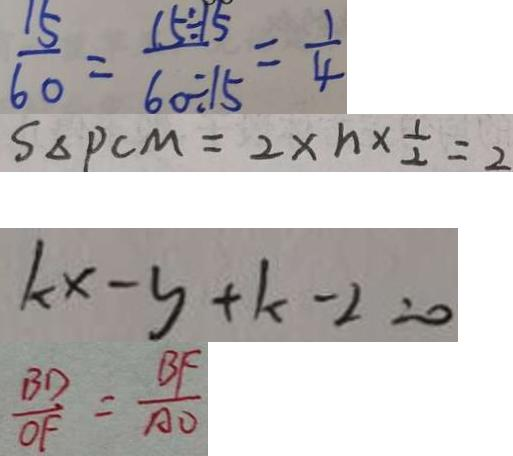<formula> <loc_0><loc_0><loc_500><loc_500>\frac { 1 5 } { 6 0 } = \frac { 1 5 \div 5 } { 6 0 \div 1 5 } = \frac { 1 } { 4 } 
 S _ { \Delta P C M } = 2 \times n \times \frac { 1 } { 2 } = 2 
 k x - y + k - 2 = 0 
 \frac { B D } { O F } = \frac { B F } { A O }</formula> 